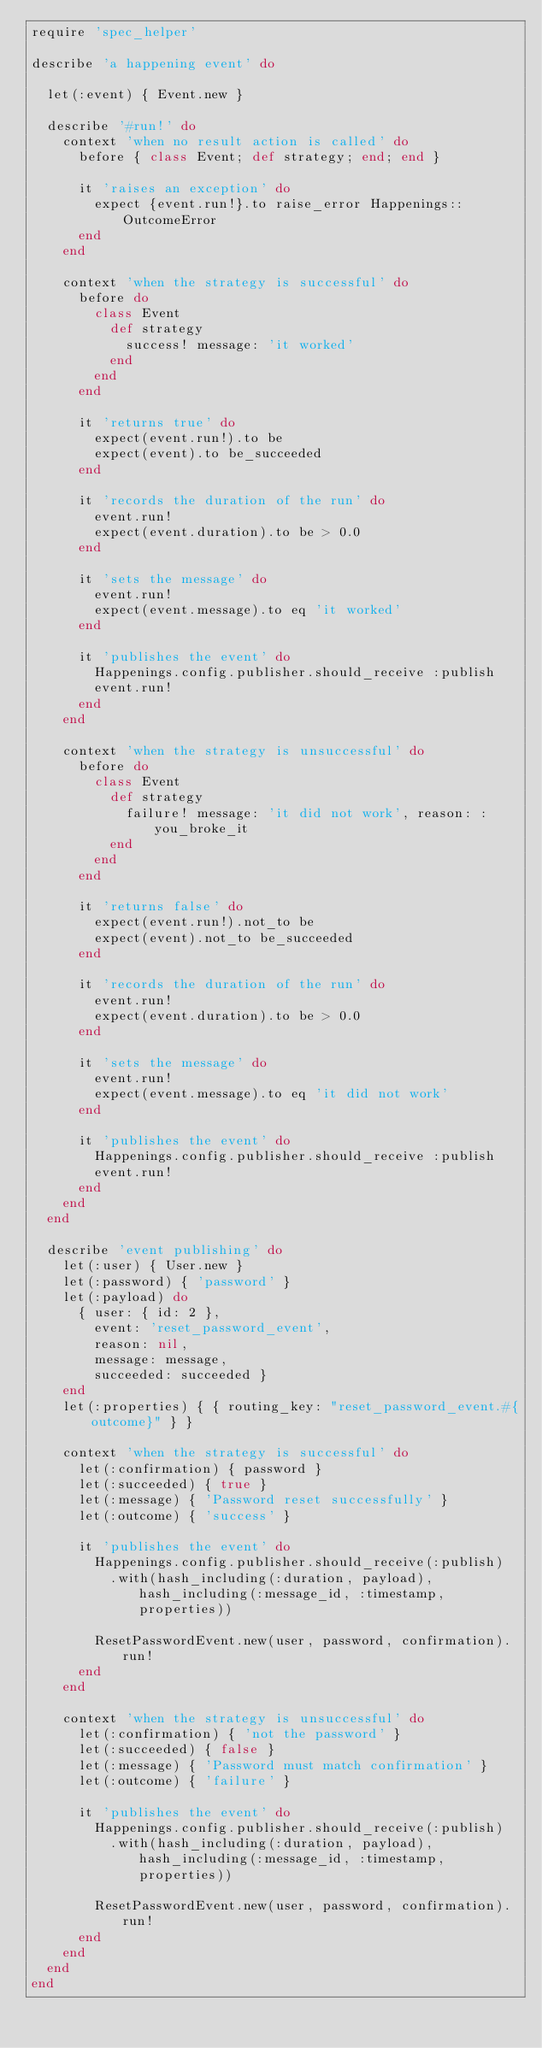<code> <loc_0><loc_0><loc_500><loc_500><_Ruby_>require 'spec_helper'

describe 'a happening event' do

  let(:event) { Event.new }

  describe '#run!' do
    context 'when no result action is called' do
      before { class Event; def strategy; end; end }

      it 'raises an exception' do
        expect {event.run!}.to raise_error Happenings::OutcomeError
      end
    end

    context 'when the strategy is successful' do
      before do
        class Event
          def strategy
            success! message: 'it worked'
          end
        end
      end

      it 'returns true' do
        expect(event.run!).to be
        expect(event).to be_succeeded
      end

      it 'records the duration of the run' do
        event.run!
        expect(event.duration).to be > 0.0
      end

      it 'sets the message' do
        event.run!
        expect(event.message).to eq 'it worked'
      end

      it 'publishes the event' do
        Happenings.config.publisher.should_receive :publish
        event.run!
      end
    end

    context 'when the strategy is unsuccessful' do
      before do
        class Event
          def strategy
            failure! message: 'it did not work', reason: :you_broke_it
          end
        end
      end

      it 'returns false' do
        expect(event.run!).not_to be
        expect(event).not_to be_succeeded
      end

      it 'records the duration of the run' do
        event.run!
        expect(event.duration).to be > 0.0
      end

      it 'sets the message' do
        event.run!
        expect(event.message).to eq 'it did not work'
      end

      it 'publishes the event' do
        Happenings.config.publisher.should_receive :publish
        event.run!
      end
    end
  end

  describe 'event publishing' do
    let(:user) { User.new }
    let(:password) { 'password' }
    let(:payload) do
      { user: { id: 2 },
        event: 'reset_password_event',
        reason: nil,
        message: message,
        succeeded: succeeded }
    end
    let(:properties) { { routing_key: "reset_password_event.#{outcome}" } }

    context 'when the strategy is successful' do
      let(:confirmation) { password }
      let(:succeeded) { true }
      let(:message) { 'Password reset successfully' }
      let(:outcome) { 'success' }

      it 'publishes the event' do
        Happenings.config.publisher.should_receive(:publish)
          .with(hash_including(:duration, payload), hash_including(:message_id, :timestamp, properties))

        ResetPasswordEvent.new(user, password, confirmation).run!
      end
    end

    context 'when the strategy is unsuccessful' do
      let(:confirmation) { 'not the password' }
      let(:succeeded) { false }
      let(:message) { 'Password must match confirmation' }
      let(:outcome) { 'failure' }

      it 'publishes the event' do
        Happenings.config.publisher.should_receive(:publish)
          .with(hash_including(:duration, payload), hash_including(:message_id, :timestamp, properties))

        ResetPasswordEvent.new(user, password, confirmation).run!
      end
    end
  end
end
</code> 